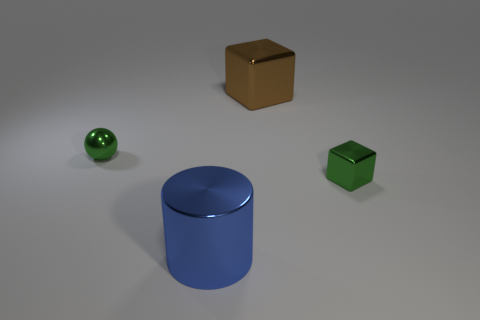Is there any other thing that has the same color as the metal cylinder?
Offer a terse response. No. There is another big object that is made of the same material as the blue thing; what shape is it?
Your response must be concise. Cube. There is a green thing on the left side of the shiny cube to the left of the green block; what number of small green objects are right of it?
Your response must be concise. 1. There is a thing that is both to the left of the big brown cube and in front of the tiny metal sphere; what shape is it?
Your answer should be compact. Cylinder. Are there fewer brown objects that are in front of the blue shiny object than large metallic blocks?
Offer a terse response. Yes. How many small things are green shiny blocks or yellow metal blocks?
Give a very brief answer. 1. What is the size of the blue object?
Keep it short and to the point. Large. There is a large cylinder; what number of small things are in front of it?
Give a very brief answer. 0. What size is the metallic object that is in front of the shiny ball and to the left of the large brown metallic block?
Your answer should be compact. Large. Does the metal sphere have the same color as the small object on the right side of the large blue object?
Provide a succinct answer. Yes. 